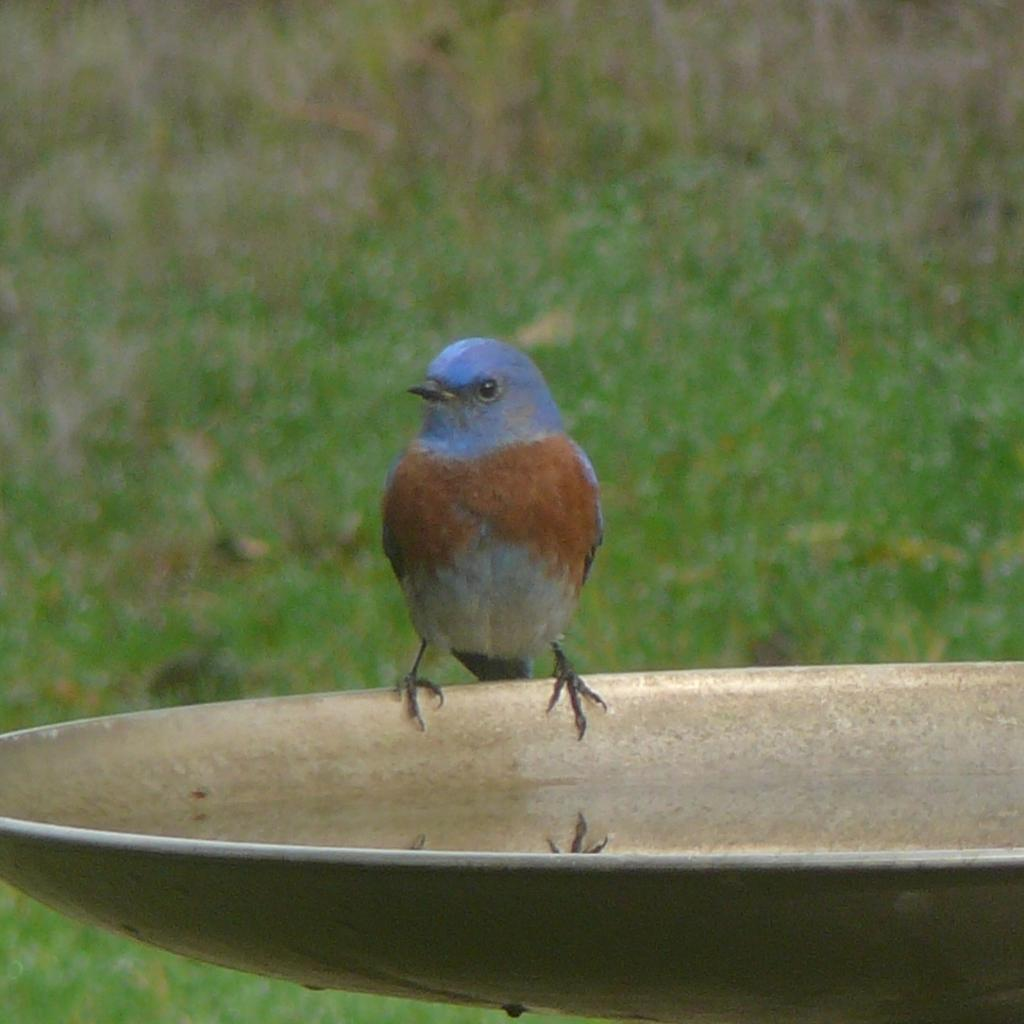What type of animal can be seen in the image? There is a bird in the image. Where is the bird located? The bird is sitting on a plate. What is in the plate with the bird? There is water in the plate. What is the background of the image? There is green grass at the bottom of the image. What color is the bird? The bird is blue in color. Where is the plant located in the image? There is no plant present in the image. What type of lamp is hanging above the bird in the image? There is no lamp present in the image. 